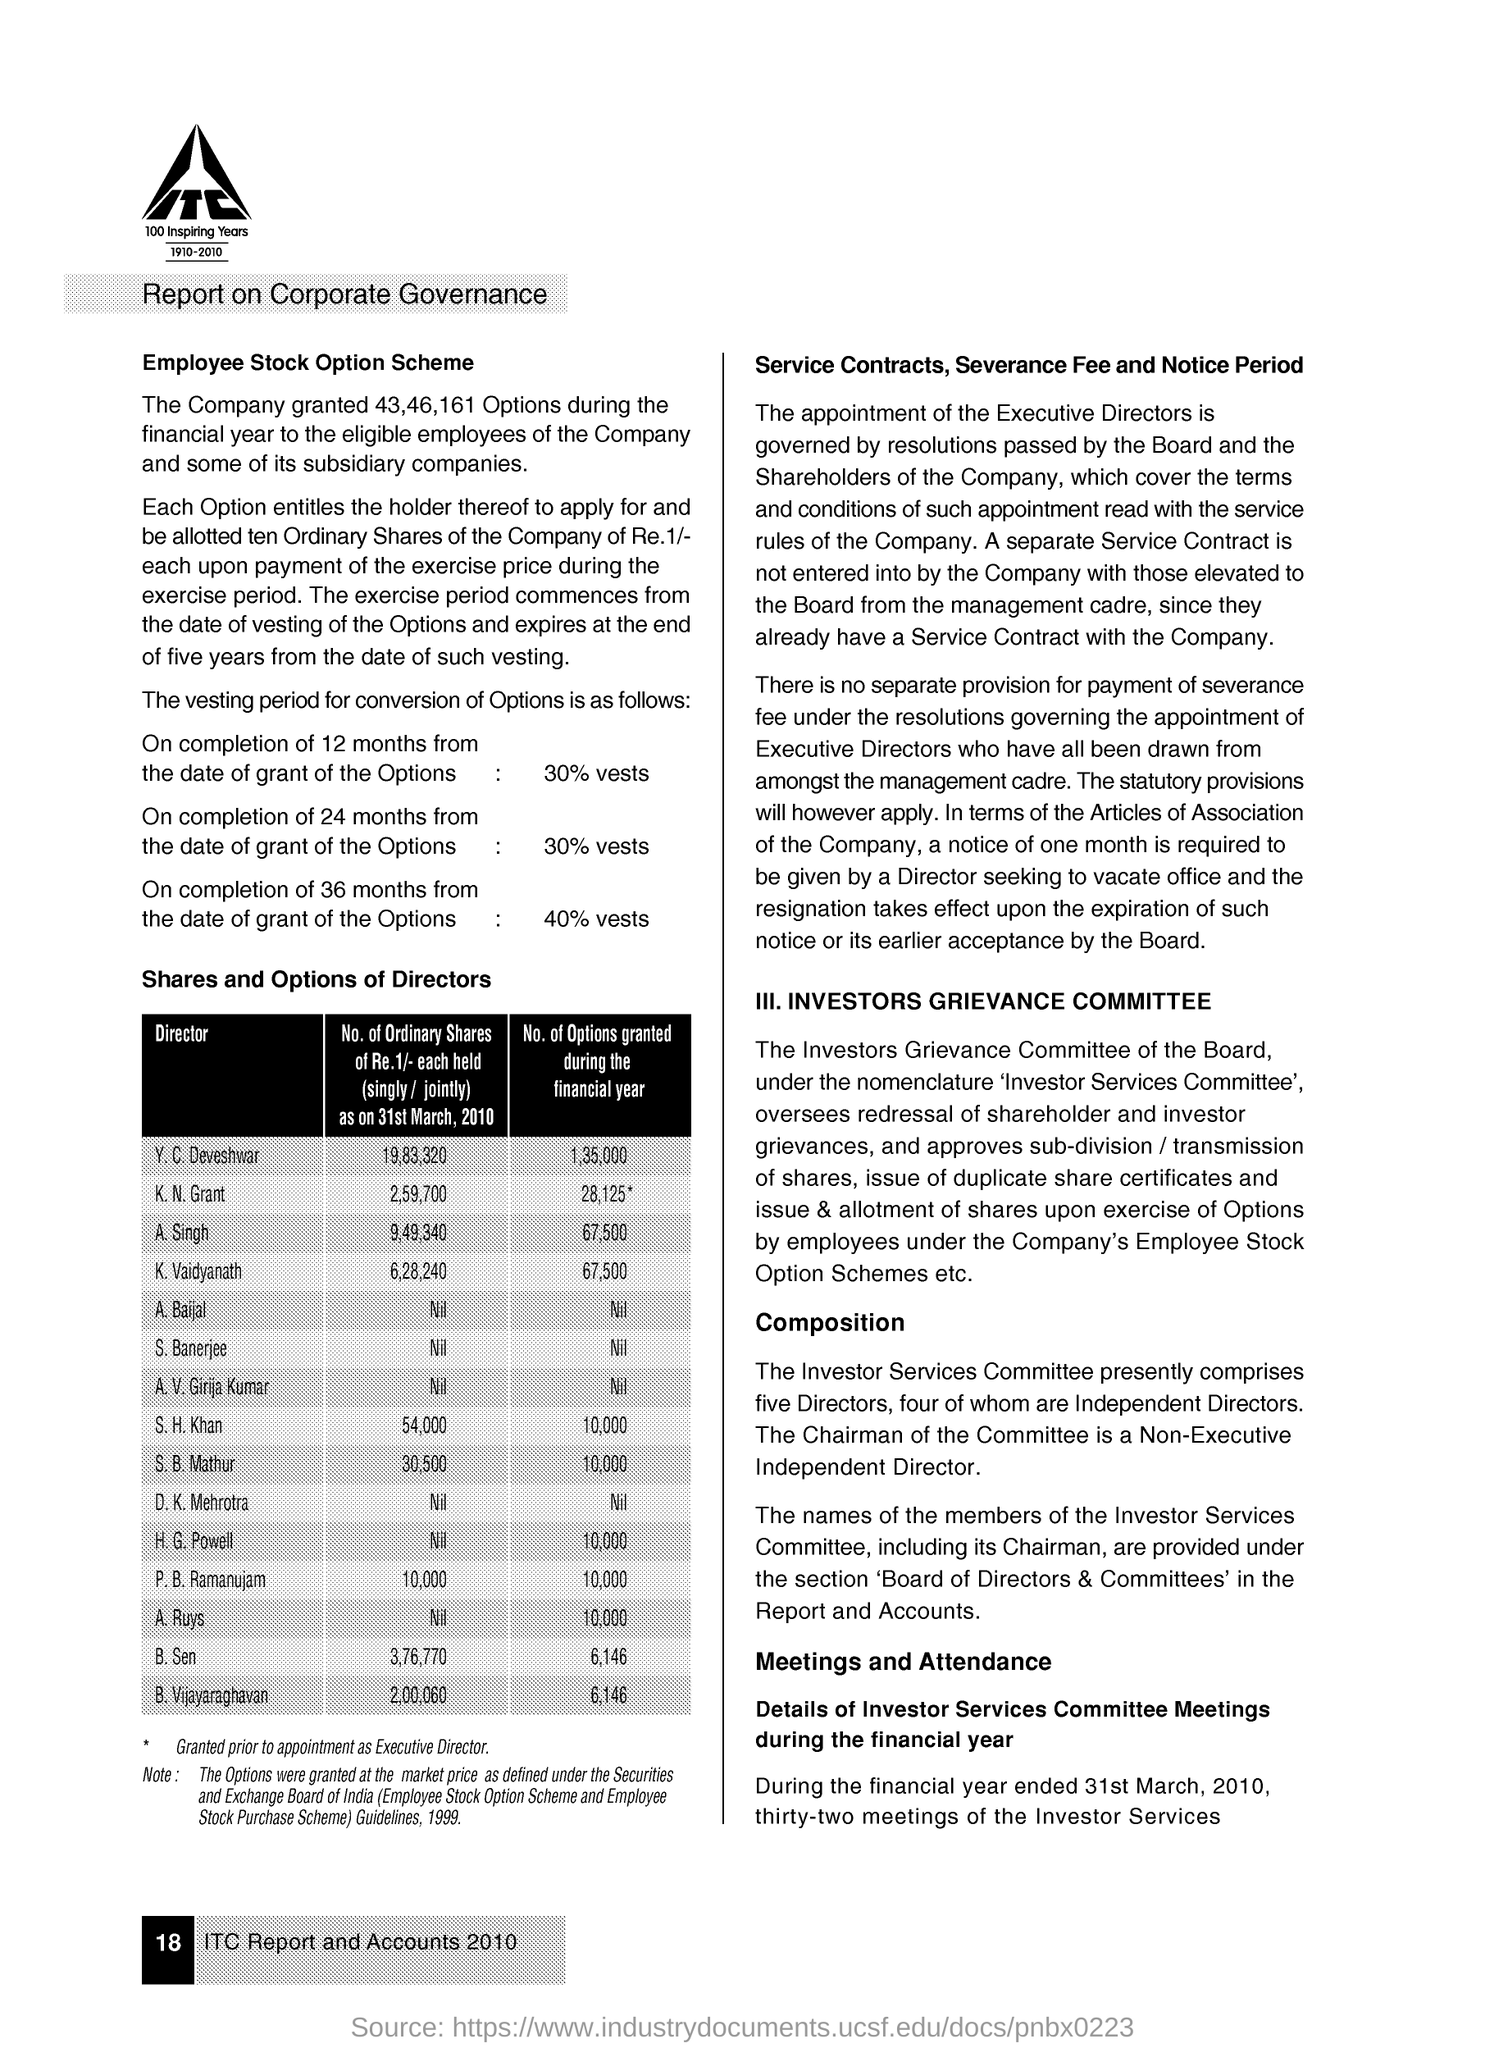What are the No. of  Options granted during the financial year to Y. C. Deveshwar?
Your answer should be compact. 1,35,000. What are the No. of  Options granted during the financial year to S. H. Khan?
Your response must be concise. 10,000. What are the No. of  Options granted during the financial year to B. Sen?
Make the answer very short. 6,146. What percentage of Options will be vested over a period of 12 months from the date of grant of the Options?
Your response must be concise. 30% vests. What percentage of Options will be vested over a period of 36 months from the date of grant of the Options?
Provide a succinct answer. 40%. What is the page no mentioned in this document?
Keep it short and to the point. 18. 